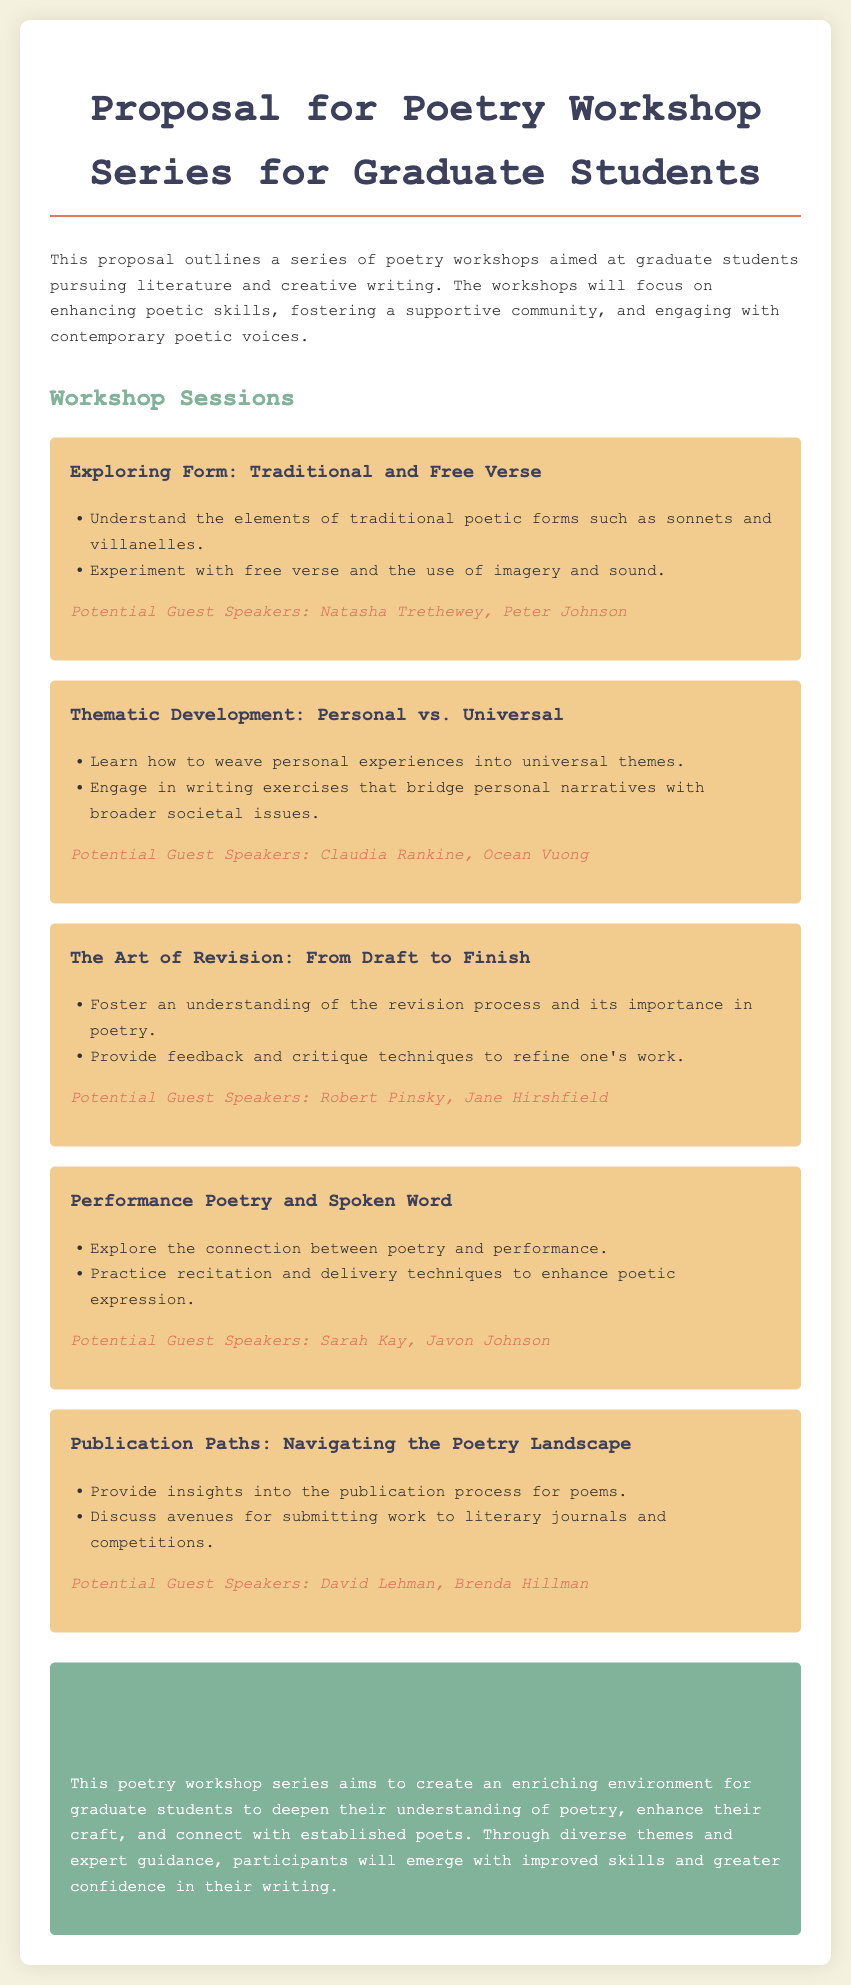What is the title of the proposal? The title of the proposal is stated at the beginning of the document.
Answer: Proposal for Poetry Workshop Series for Graduate Students How many workshop sessions are outlined in the proposal? The document lists multiple workshop sessions, specifically counting the number of sessions mentioned.
Answer: Five Who is the potential guest speaker for the session on traditional and free verse? The potential guest speakers are listed under each workshop session, specifically for the first session.
Answer: Natasha Trethewey, Peter Johnson What is the focus of the workshop session "The Art of Revision"? The document provides a brief description of each session's focus, including the themes covered in "The Art of Revision."
Answer: Revision process and feedback techniques Which session encourages weaving personal experiences into universal themes? The document includes specific learning objectives for each session, identifying the focus of the session.
Answer: Thematic Development: Personal vs. Universal What color is used for the background of the conclusion section? The conclusion section is described with specific characteristics regarding color in the document.
Answer: #81b29a What is the main goal of the poetry workshop series? The document outlines the overall goal of the workshop series within the conclusion section.
Answer: Create an enriching environment Who are the potential guest speakers for the session on publication paths? The potential guest speakers are provided under the relevant session, indicating who might lead that session.
Answer: David Lehman, Brenda Hillman 